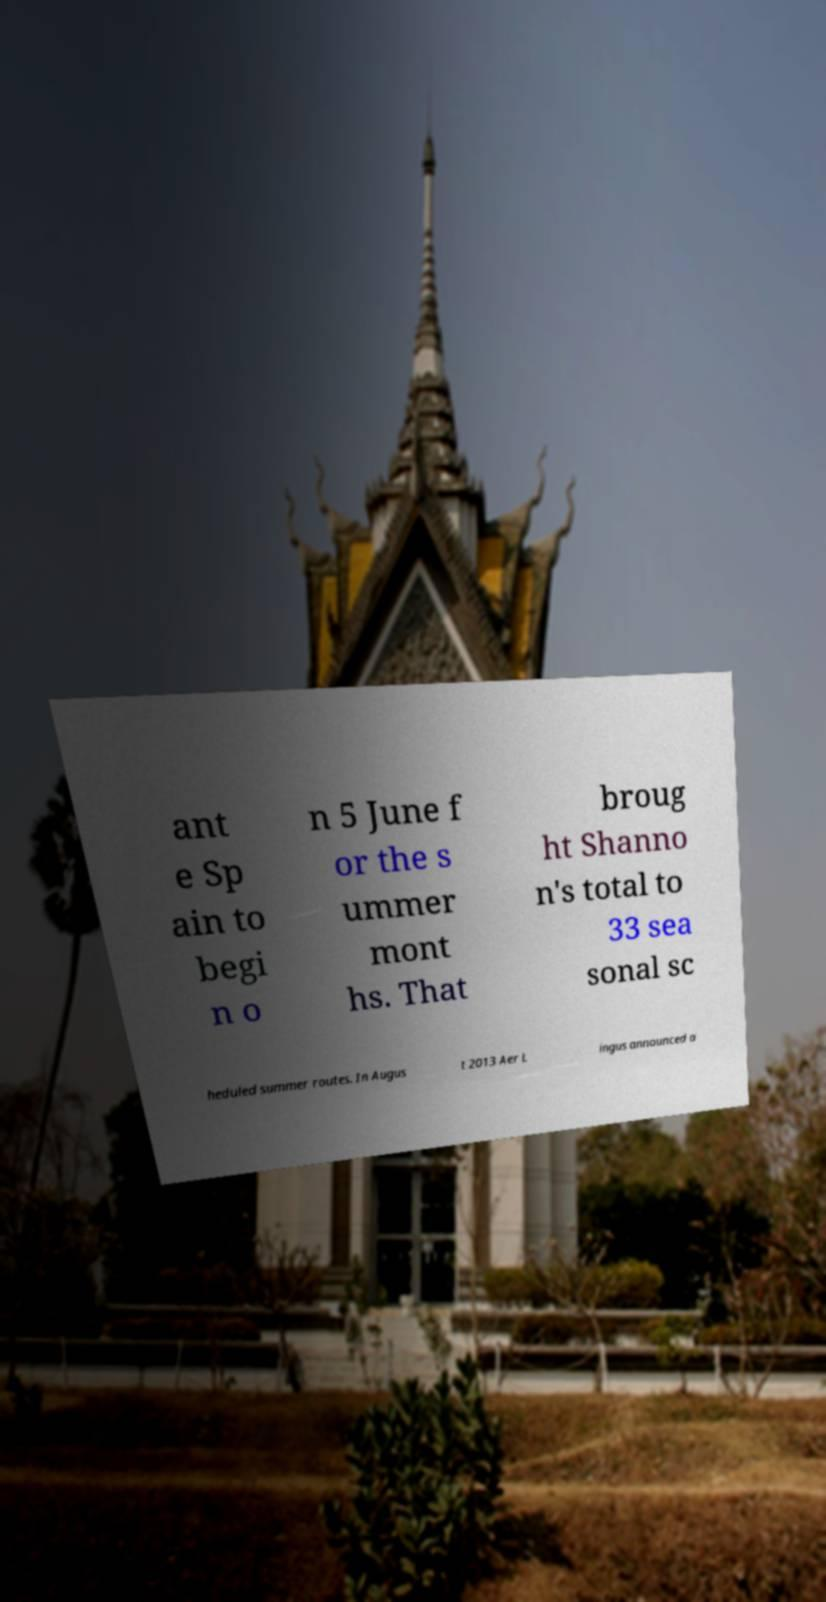What messages or text are displayed in this image? I need them in a readable, typed format. ant e Sp ain to begi n o n 5 June f or the s ummer mont hs. That broug ht Shanno n's total to 33 sea sonal sc heduled summer routes. In Augus t 2013 Aer L ingus announced a 